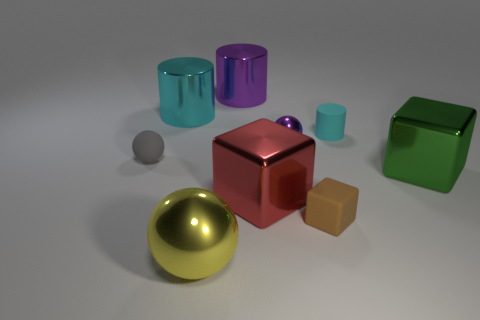Subtract all cyan cylinders. How many were subtracted if there are1cyan cylinders left? 1 Add 1 tiny purple metallic things. How many objects exist? 10 Subtract all spheres. How many objects are left? 6 Add 3 purple cylinders. How many purple cylinders exist? 4 Subtract 0 cyan blocks. How many objects are left? 9 Subtract all big green shiny balls. Subtract all purple things. How many objects are left? 7 Add 8 large cyan shiny things. How many large cyan shiny things are left? 9 